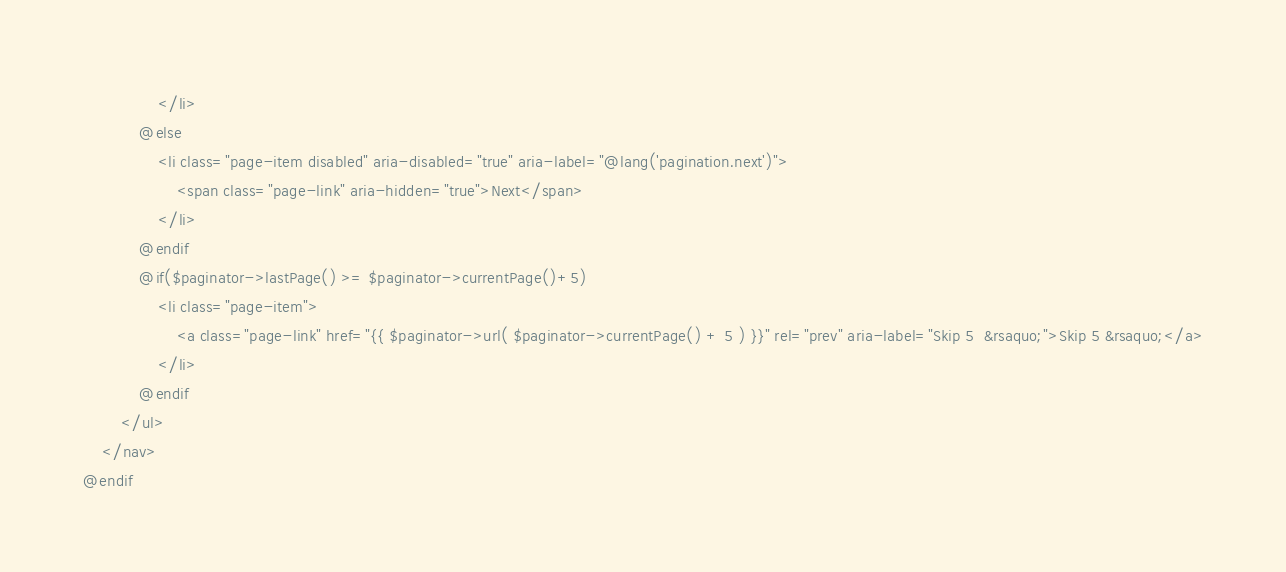<code> <loc_0><loc_0><loc_500><loc_500><_PHP_>                </li>
            @else
                <li class="page-item disabled" aria-disabled="true" aria-label="@lang('pagination.next')">
                    <span class="page-link" aria-hidden="true">Next</span>
                </li>
            @endif
            @if($paginator->lastPage() >= $paginator->currentPage()+5)
                <li class="page-item">
                    <a class="page-link" href="{{ $paginator->url( $paginator->currentPage() + 5 ) }}" rel="prev" aria-label="Skip 5  &rsaquo;">Skip 5 &rsaquo;</a>
                </li>
            @endif
        </ul>
    </nav>
@endif</code> 